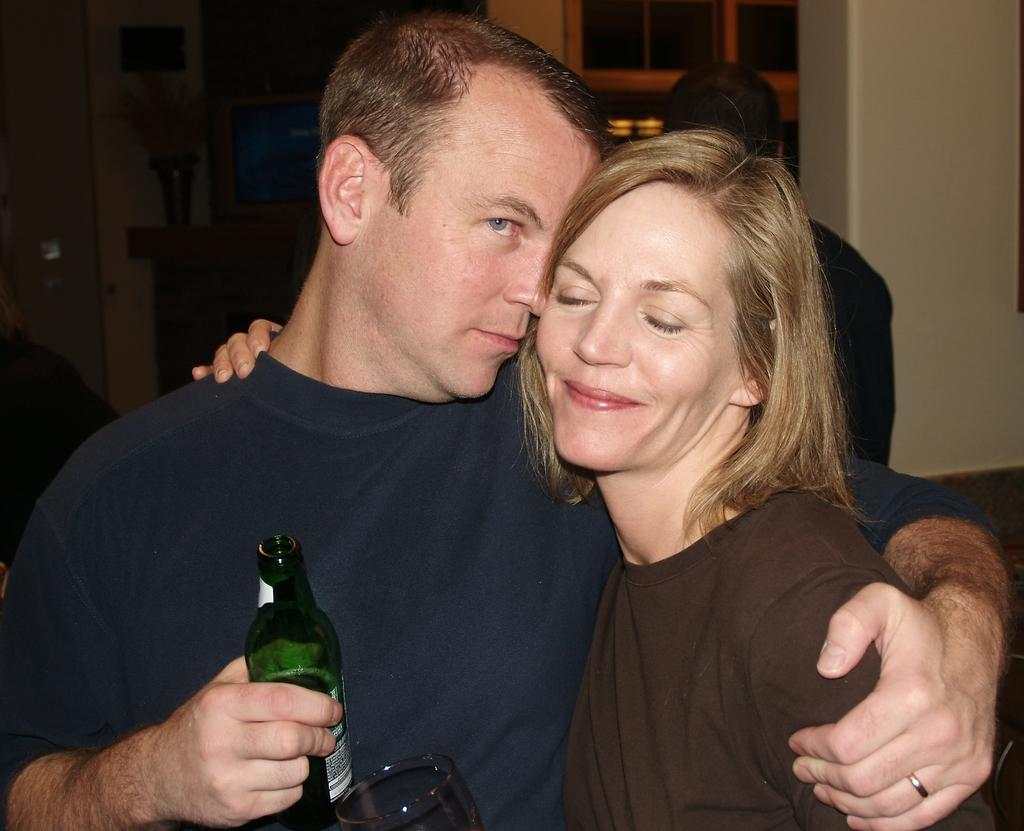How many people are present in the image? There are two people, a man and a woman, present in the image. What is the expression of the woman in the image? The woman is smiling. What is the man holding in the image? The man is holding a bottle. Can you describe the person in the background of the image? There is a person in the background of the image, but no specific details are provided. What is another object visible in the image? There is a glass visible in the image. What type of toothpaste is the man using in the image? There is no toothpaste present in the image; the man is holding a bottle, but its contents are not specified. What shape is the pail that the woman is holding in the image? There is no pail present in the image; the woman is simply smiling and no objects are mentioned in her hands. 